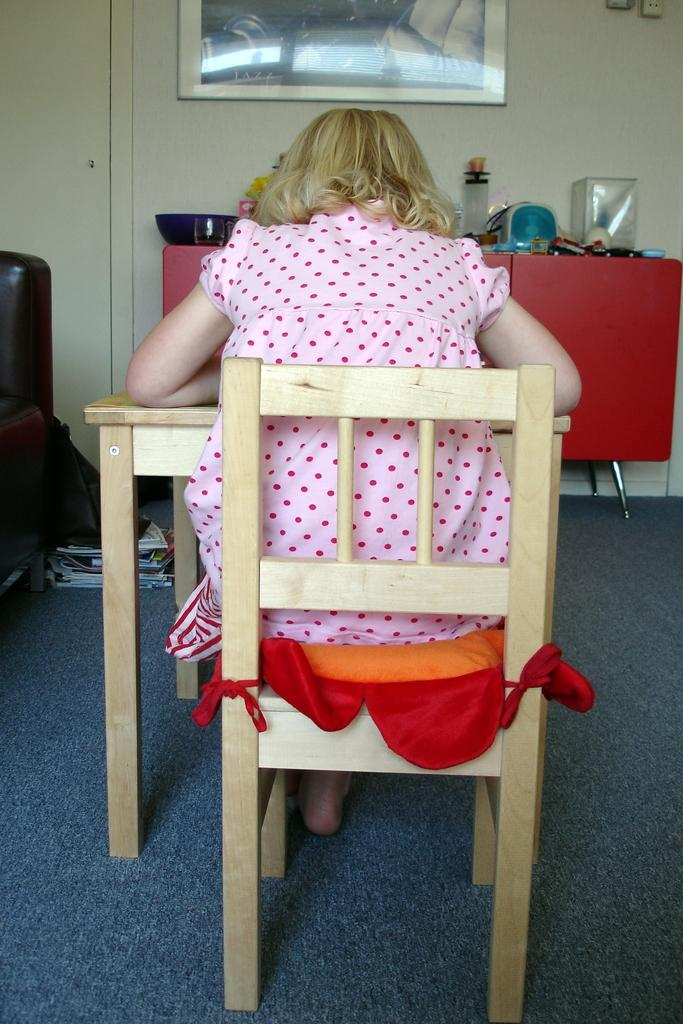What is the girl doing in the image? The girl is sitting on a chair in the image. How is the girl positioned in relation to the table? The girl is resting her hands on a table. What can be seen on the wall in the image? There is a photograph on the wall. What type of background is visible in the image? There is a wall in the image. What type of condition does the giraffe have in the image? There is no giraffe present in the image, so it is not possible to determine any condition related to a giraffe. 